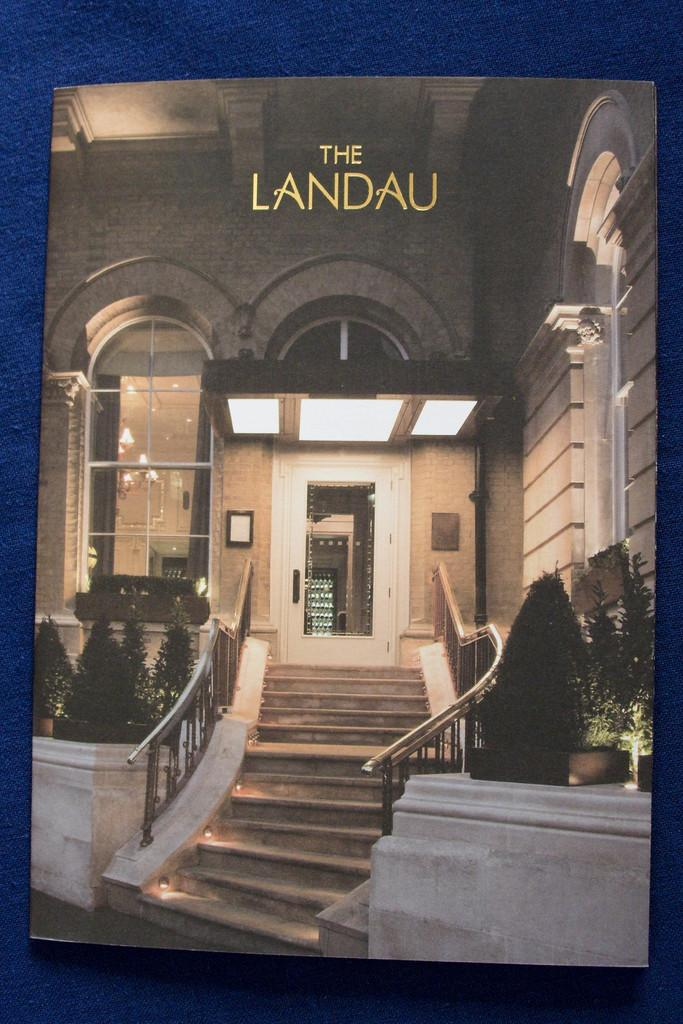<image>
Give a short and clear explanation of the subsequent image. A hotel brochure advertises an establishment called The Landau. 